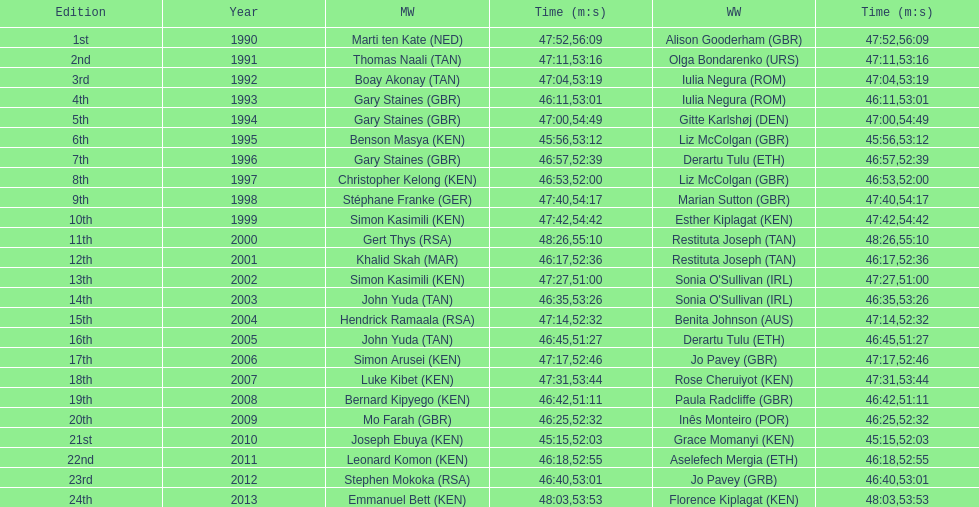The other women's winner with the same finish time as jo pavey in 2012 Iulia Negura. 